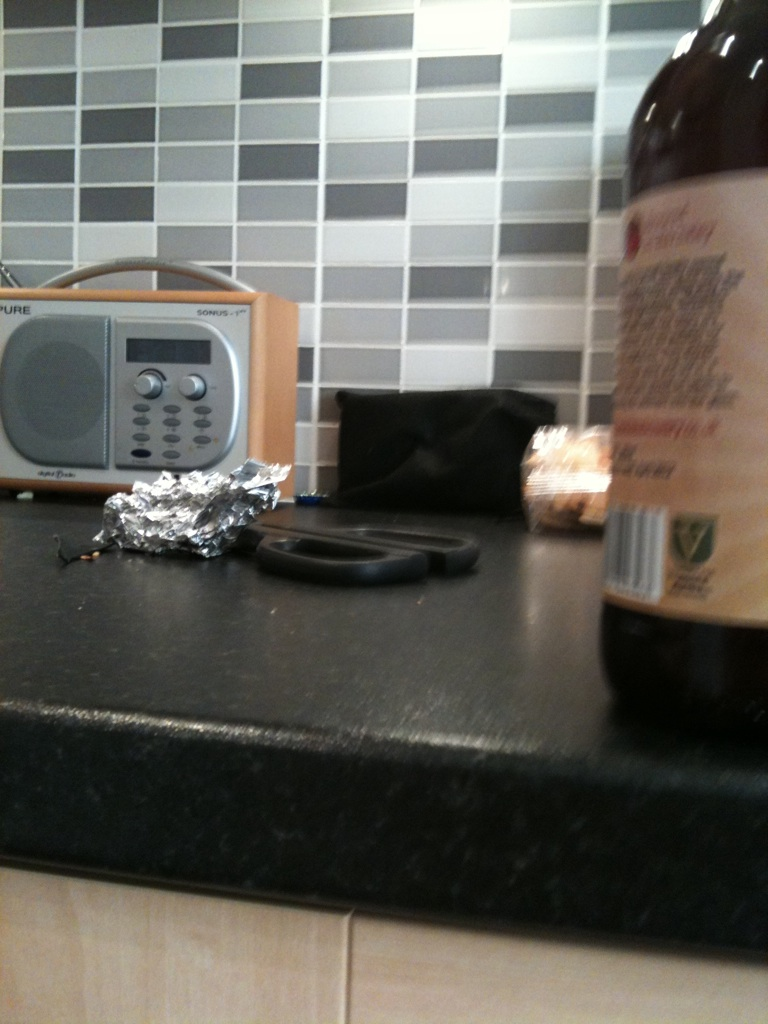What do you think are the most used items on this kitchen counter? The most used items on this kitchen counter seem to be the radio, the foil, and the scissors. The radio might commonly be used for listening to music or news while cooking. The foil looks like it might have been recently used for wrapping food, and the scissors probably come in handy for various tasks like opening packaging or cutting herbs. What kind of meals do you think are prepared in this kitchen? Given the practical setup of this kitchen, it appears well-suited for preparing everyday meals that are hearty and convenient. Perhaps simple, homestyle cooking such as soups, stews, and casseroles, alongside fresh salads and sandwiches. The presence of aluminum foil suggests regular baking or roasting might be a common activity here. Why do you think there's a radio on the counter? The radio evident on the counter likely serves to provide entertainment and companionship during meal preparation. It can play background music, offer news updates, or broadcast favorite radio shows, making the kitchen a more enjoyable and lively space. 